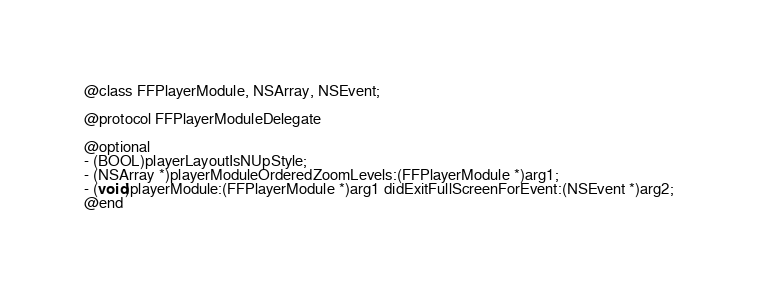<code> <loc_0><loc_0><loc_500><loc_500><_C_>@class FFPlayerModule, NSArray, NSEvent;

@protocol FFPlayerModuleDelegate

@optional
- (BOOL)playerLayoutIsNUpStyle;
- (NSArray *)playerModuleOrderedZoomLevels:(FFPlayerModule *)arg1;
- (void)playerModule:(FFPlayerModule *)arg1 didExitFullScreenForEvent:(NSEvent *)arg2;
@end

</code> 